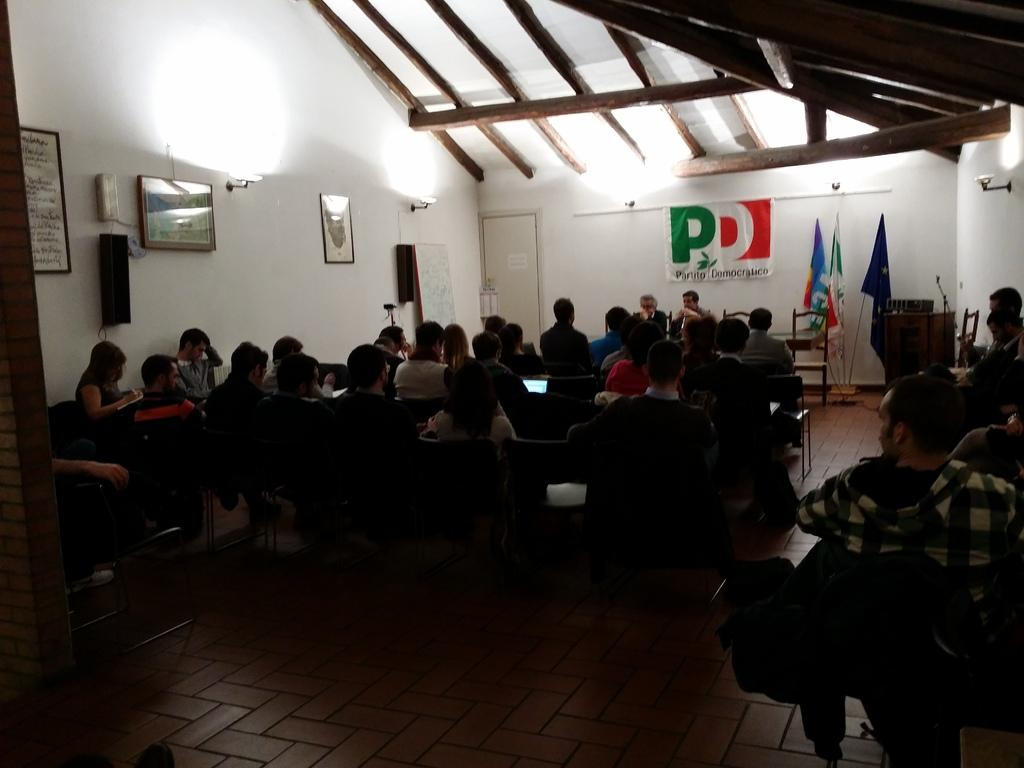What are the people in the image doing? The people in the image are sitting on chairs. What can be seen behind the people in the image? There are walls visible in the image. What is hanging on the walls in the image? There are photo frames on the walls. What else is present in the image besides the people and walls? There are flags in the image. Can you tell me how many ghosts are present in the image? There are no ghosts present in the image. What type of secretary can be seen working in the image? There is no secretary present in the image. 